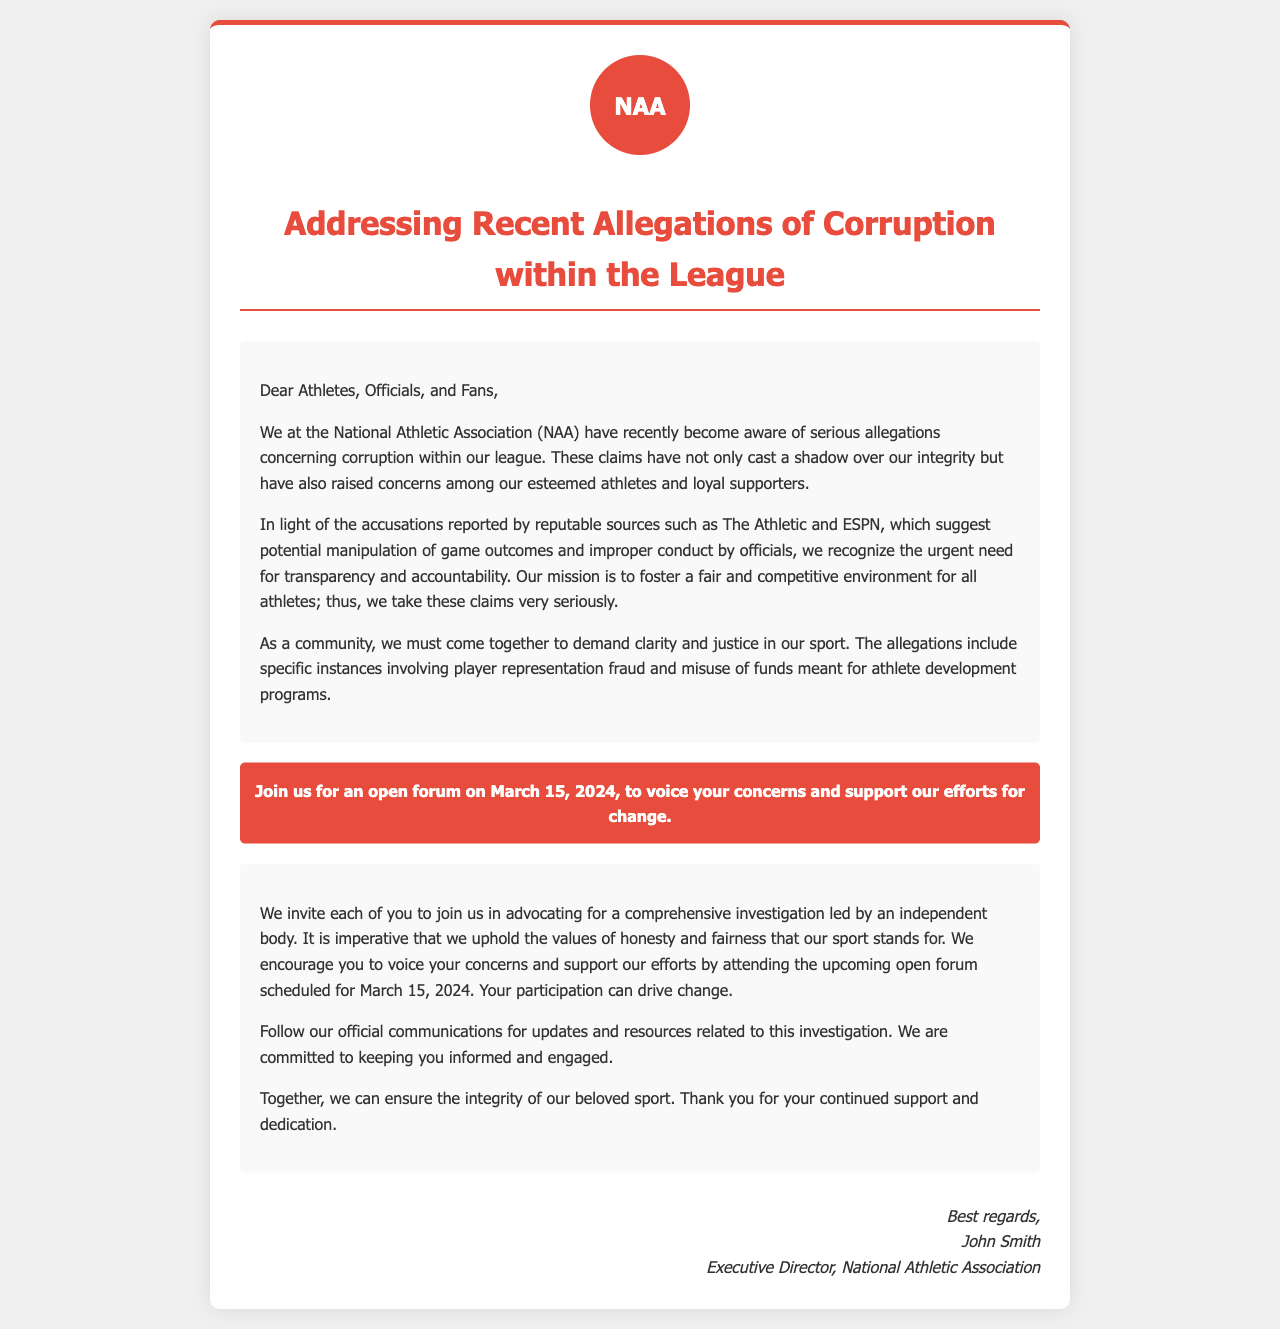What is the name of the association mentioned? The document refers to the National Athletic Association as the governing body addressing the issues.
Answer: National Athletic Association Who is the executive director? The signature section includes the name of the executive director who signed the letter.
Answer: John Smith What is the date of the open forum? The document specifies a date for the upcoming open forum where concerns can be voiced.
Answer: March 15, 2024 Which platforms reported the allegations? The letter mentions reputable sources that reported allegations concerning corruption.
Answer: The Athletic and ESPN What kind of investigation is being called for? The community is encouraged to advocate for a specific type of investigation regarding the allegations.
Answer: Comprehensive investigation What is at stake according to the letter? The letter highlights the implications of the allegations to the integrity of the sport.
Answer: Integrity of the sport What is the purpose of the open forum? The document explains the gathering's intent to allow individuals to express their thoughts and support necessary actions.
Answer: Voice concerns and support efforts for change What should the community come together to demand? The letter urges collective action focused on a specific goal in light of the allegations.
Answer: Clarity and justice 